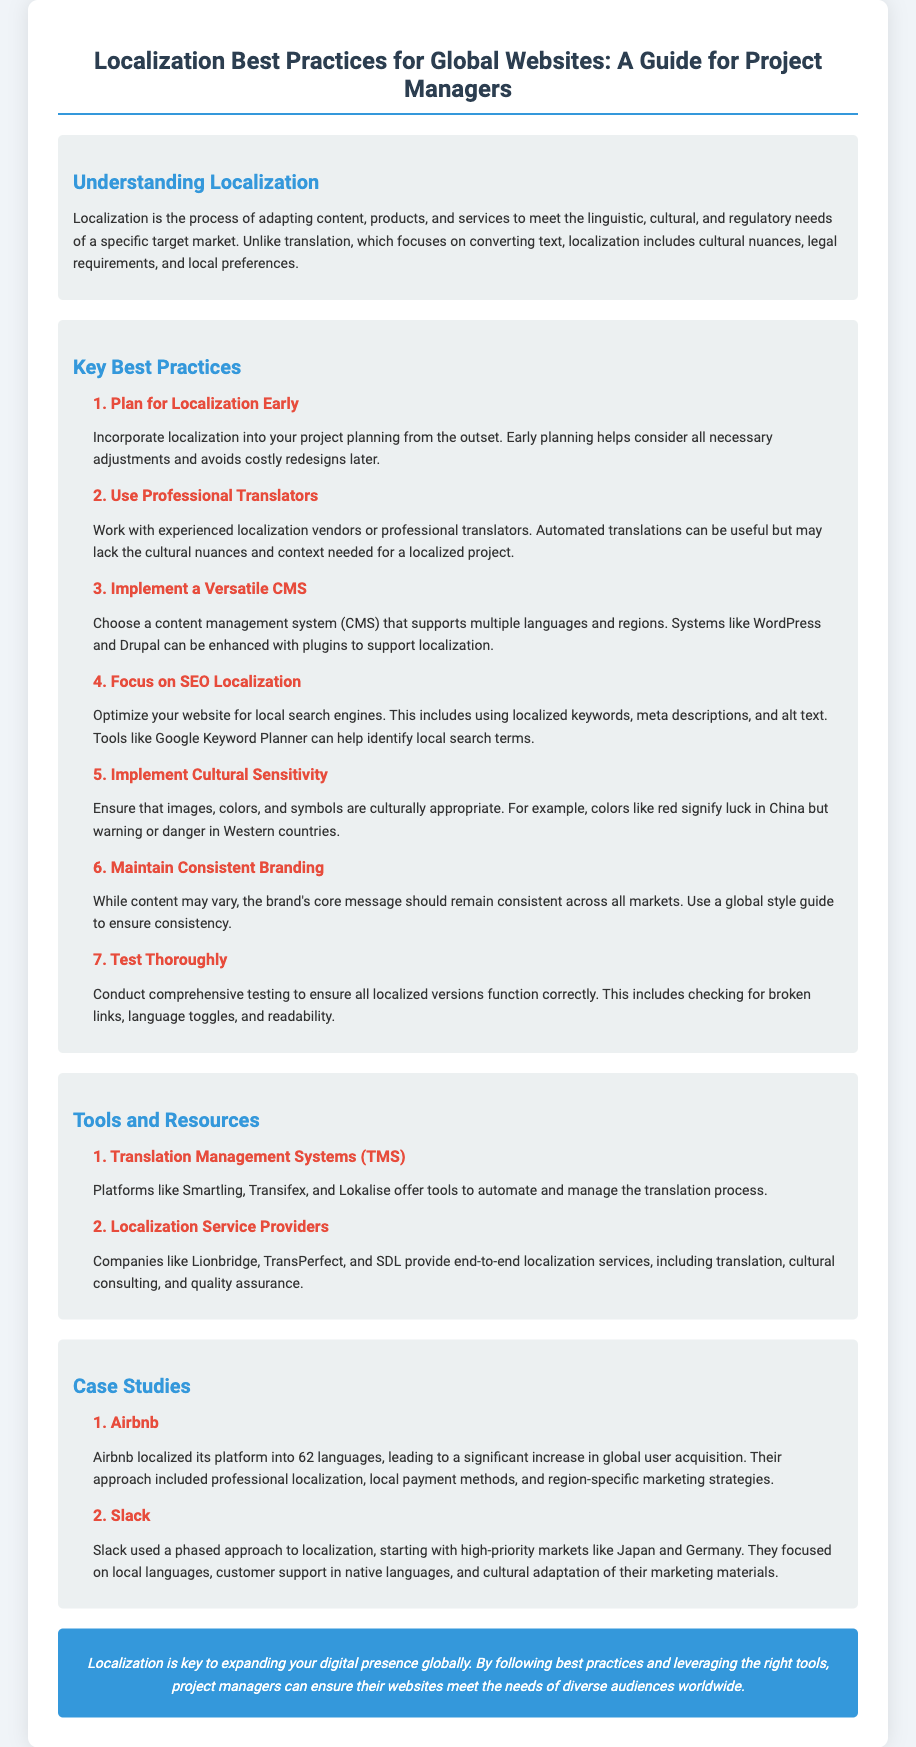What is the title of the guide? The title of the guide is the main heading presented at the top of the document.
Answer: Localization Best Practices for Global Websites: A Guide for Project Managers What is the first best practice listed? The first best practice is clearly outlined in the section on Key Best Practices.
Answer: Plan for Localization Early Which company localized its platform into 62 languages? This information can be found in the Case Studies section, where specific examples of companies are given.
Answer: Airbnb What should be optimized for local search engines? This is mentioned in the best practices regarding SEO localization.
Answer: Website What color signifies luck in China? The document provides examples related to cultural sensitivity, including color interpretations.
Answer: Red How many best practices are listed in total? The total number of best practices can be counted in the Key Best Practices section.
Answer: Seven What do Translation Management Systems do? The role of Translation Management Systems is described in the Tools and Resources section.
Answer: Automate and manage the translation process Which service providers offer end-to-end localization services? This information is available in the Tools and Resources section, listing specific companies.
Answer: Lionbridge, TransPerfect, SDL 